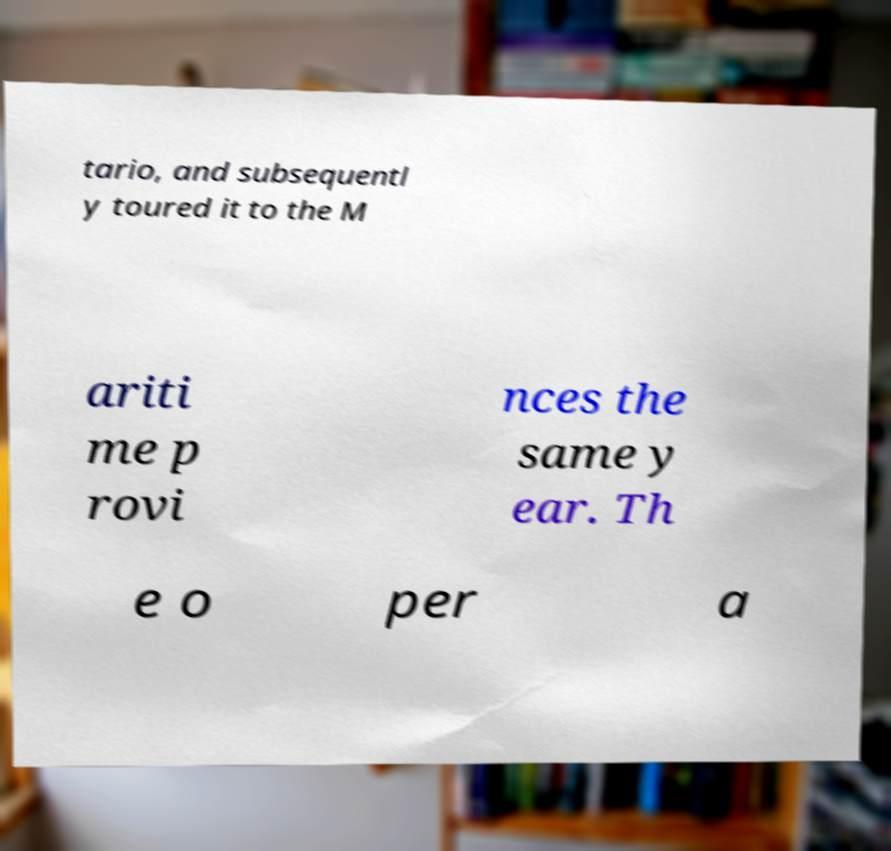Can you accurately transcribe the text from the provided image for me? tario, and subsequentl y toured it to the M ariti me p rovi nces the same y ear. Th e o per a 